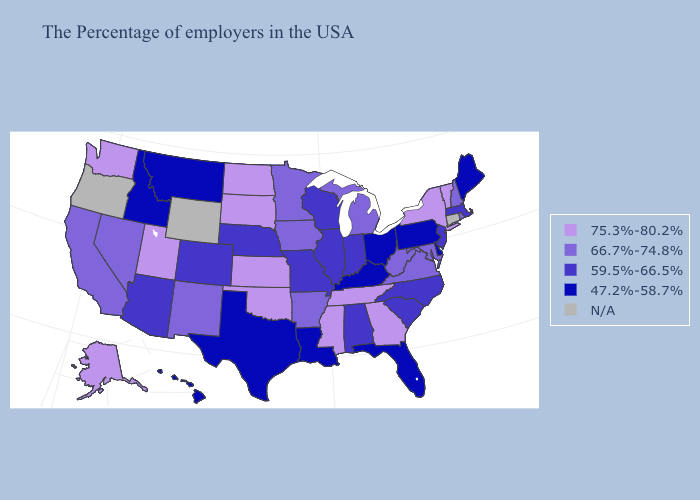Among the states that border Ohio , which have the highest value?
Concise answer only. West Virginia, Michigan. Does the map have missing data?
Quick response, please. Yes. Name the states that have a value in the range 66.7%-74.8%?
Give a very brief answer. Rhode Island, New Hampshire, Maryland, Virginia, West Virginia, Michigan, Arkansas, Minnesota, Iowa, New Mexico, Nevada, California. Does Texas have the lowest value in the USA?
Keep it brief. Yes. What is the value of Utah?
Answer briefly. 75.3%-80.2%. Which states have the lowest value in the USA?
Short answer required. Maine, Delaware, Pennsylvania, Ohio, Florida, Kentucky, Louisiana, Texas, Montana, Idaho, Hawaii. What is the value of North Carolina?
Be succinct. 59.5%-66.5%. Among the states that border New Hampshire , does Vermont have the highest value?
Write a very short answer. Yes. Among the states that border Delaware , which have the lowest value?
Keep it brief. Pennsylvania. Which states have the lowest value in the USA?
Answer briefly. Maine, Delaware, Pennsylvania, Ohio, Florida, Kentucky, Louisiana, Texas, Montana, Idaho, Hawaii. Among the states that border Vermont , which have the highest value?
Write a very short answer. New York. Does Indiana have the lowest value in the USA?
Quick response, please. No. What is the highest value in the USA?
Give a very brief answer. 75.3%-80.2%. What is the value of Virginia?
Be succinct. 66.7%-74.8%. 